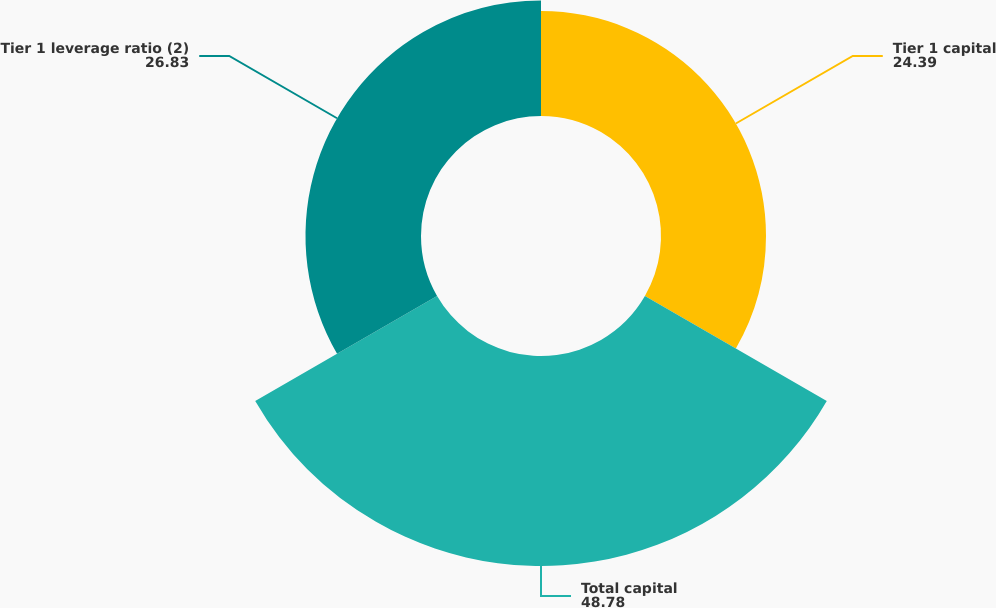Convert chart to OTSL. <chart><loc_0><loc_0><loc_500><loc_500><pie_chart><fcel>Tier 1 capital<fcel>Total capital<fcel>Tier 1 leverage ratio (2)<nl><fcel>24.39%<fcel>48.78%<fcel>26.83%<nl></chart> 